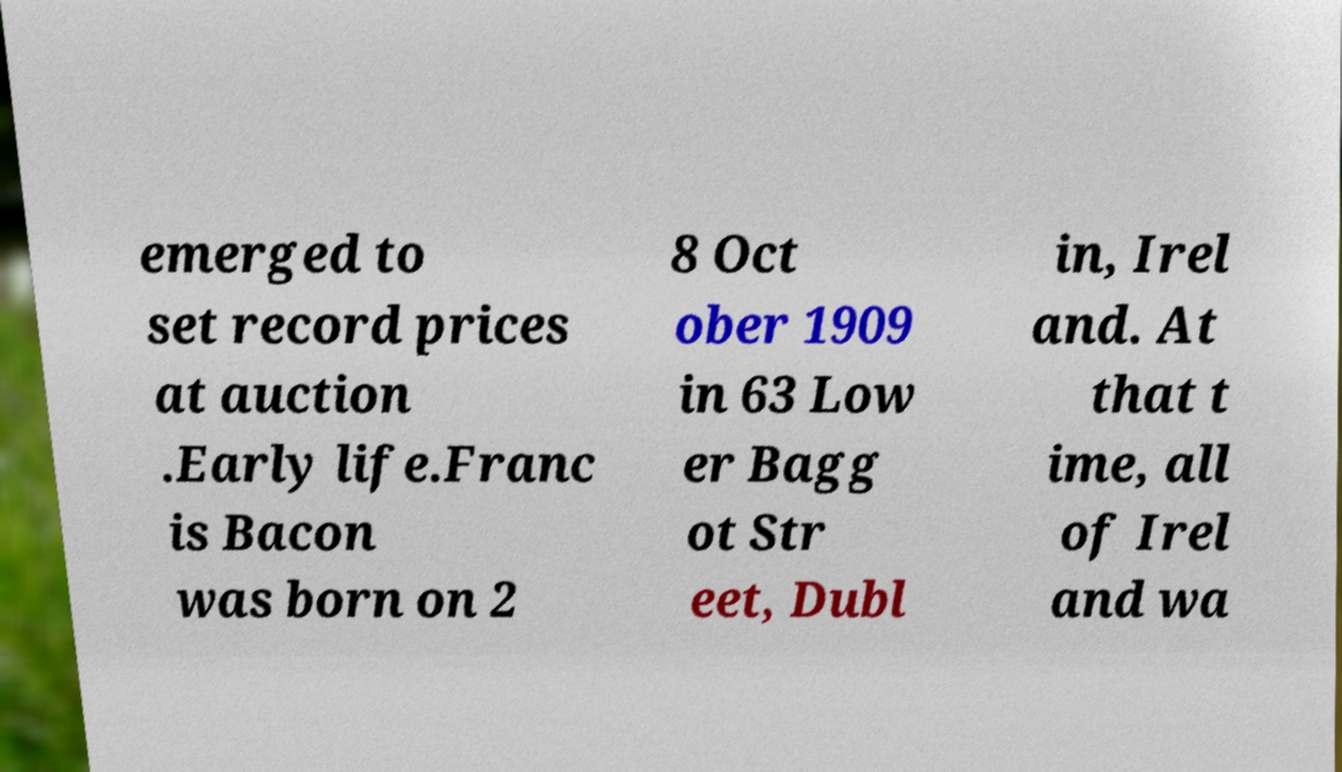Can you read and provide the text displayed in the image?This photo seems to have some interesting text. Can you extract and type it out for me? emerged to set record prices at auction .Early life.Franc is Bacon was born on 2 8 Oct ober 1909 in 63 Low er Bagg ot Str eet, Dubl in, Irel and. At that t ime, all of Irel and wa 